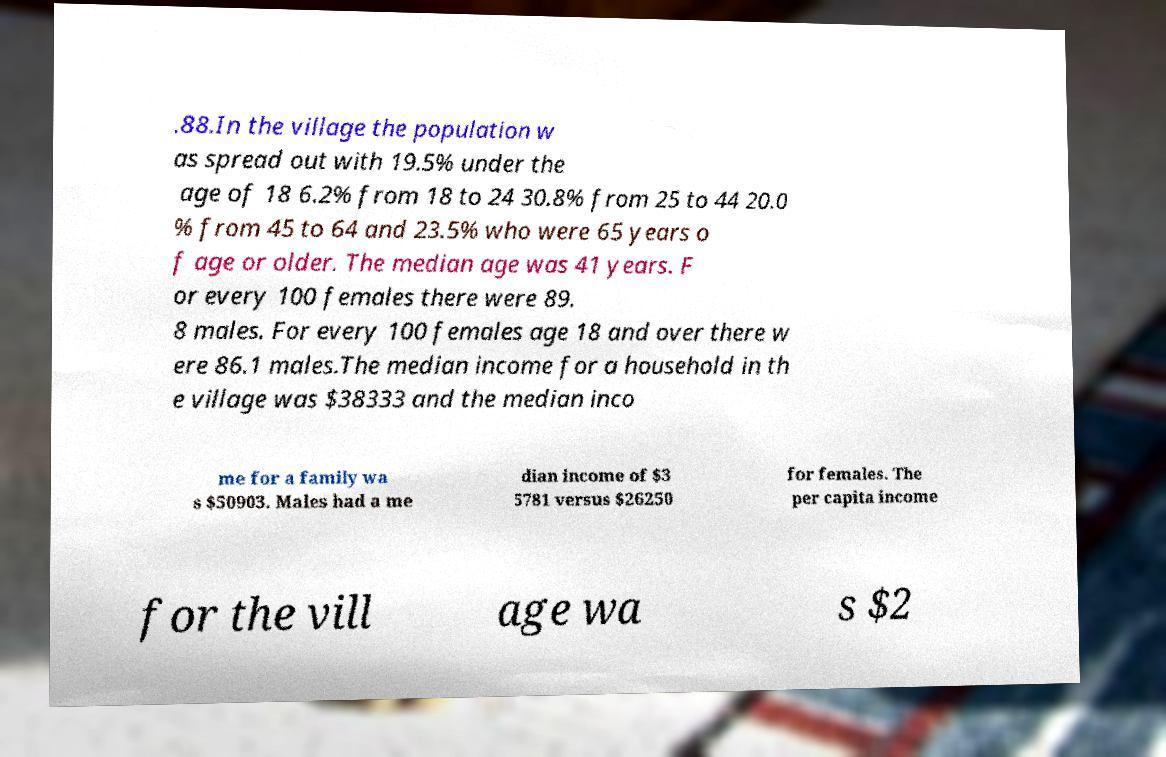Can you read and provide the text displayed in the image?This photo seems to have some interesting text. Can you extract and type it out for me? .88.In the village the population w as spread out with 19.5% under the age of 18 6.2% from 18 to 24 30.8% from 25 to 44 20.0 % from 45 to 64 and 23.5% who were 65 years o f age or older. The median age was 41 years. F or every 100 females there were 89. 8 males. For every 100 females age 18 and over there w ere 86.1 males.The median income for a household in th e village was $38333 and the median inco me for a family wa s $50903. Males had a me dian income of $3 5781 versus $26250 for females. The per capita income for the vill age wa s $2 